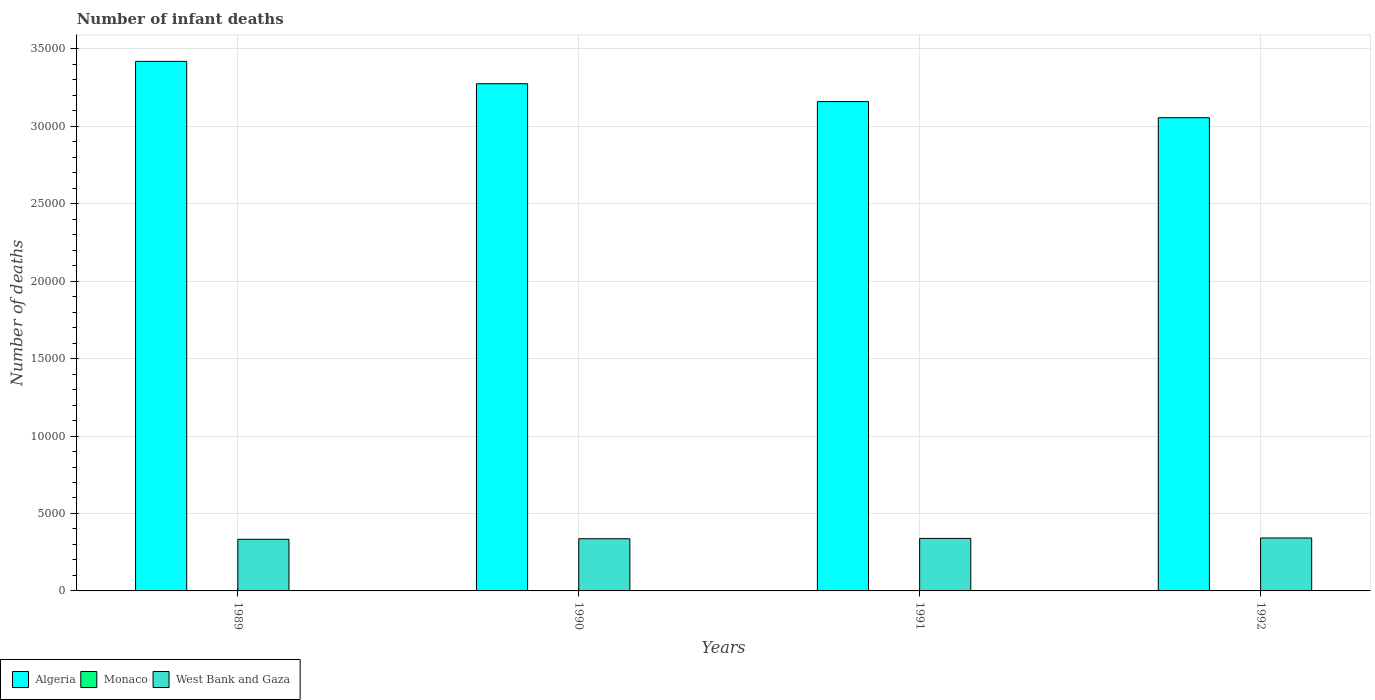How many different coloured bars are there?
Offer a terse response. 3. Are the number of bars per tick equal to the number of legend labels?
Provide a short and direct response. Yes. Are the number of bars on each tick of the X-axis equal?
Your response must be concise. Yes. What is the number of infant deaths in Monaco in 1992?
Give a very brief answer. 2. Across all years, what is the maximum number of infant deaths in Algeria?
Ensure brevity in your answer.  3.42e+04. Across all years, what is the minimum number of infant deaths in Monaco?
Ensure brevity in your answer.  1. In which year was the number of infant deaths in Monaco maximum?
Your answer should be very brief. 1990. In which year was the number of infant deaths in West Bank and Gaza minimum?
Give a very brief answer. 1989. What is the total number of infant deaths in West Bank and Gaza in the graph?
Offer a terse response. 1.35e+04. What is the difference between the number of infant deaths in Algeria in 1990 and that in 1992?
Provide a succinct answer. 2193. What is the difference between the number of infant deaths in Monaco in 1989 and the number of infant deaths in West Bank and Gaza in 1991?
Keep it short and to the point. -3389. What is the average number of infant deaths in Algeria per year?
Your answer should be compact. 3.23e+04. In the year 1990, what is the difference between the number of infant deaths in West Bank and Gaza and number of infant deaths in Monaco?
Keep it short and to the point. 3367. What is the ratio of the number of infant deaths in Monaco in 1990 to that in 1992?
Ensure brevity in your answer.  1. Is the number of infant deaths in West Bank and Gaza in 1989 less than that in 1991?
Offer a very short reply. Yes. Is the difference between the number of infant deaths in West Bank and Gaza in 1990 and 1992 greater than the difference between the number of infant deaths in Monaco in 1990 and 1992?
Provide a succinct answer. No. What is the difference between the highest and the second highest number of infant deaths in Algeria?
Provide a short and direct response. 1445. What is the difference between the highest and the lowest number of infant deaths in Algeria?
Keep it short and to the point. 3638. What does the 3rd bar from the left in 1991 represents?
Your response must be concise. West Bank and Gaza. What does the 2nd bar from the right in 1990 represents?
Give a very brief answer. Monaco. How many bars are there?
Your answer should be compact. 12. Where does the legend appear in the graph?
Provide a succinct answer. Bottom left. How are the legend labels stacked?
Provide a short and direct response. Horizontal. What is the title of the graph?
Provide a succinct answer. Number of infant deaths. Does "Israel" appear as one of the legend labels in the graph?
Make the answer very short. No. What is the label or title of the Y-axis?
Offer a very short reply. Number of deaths. What is the Number of deaths of Algeria in 1989?
Offer a terse response. 3.42e+04. What is the Number of deaths of West Bank and Gaza in 1989?
Provide a short and direct response. 3335. What is the Number of deaths of Algeria in 1990?
Keep it short and to the point. 3.27e+04. What is the Number of deaths in Monaco in 1990?
Give a very brief answer. 2. What is the Number of deaths of West Bank and Gaza in 1990?
Your answer should be compact. 3369. What is the Number of deaths in Algeria in 1991?
Give a very brief answer. 3.16e+04. What is the Number of deaths in West Bank and Gaza in 1991?
Offer a very short reply. 3390. What is the Number of deaths in Algeria in 1992?
Your response must be concise. 3.06e+04. What is the Number of deaths in Monaco in 1992?
Provide a short and direct response. 2. What is the Number of deaths in West Bank and Gaza in 1992?
Give a very brief answer. 3417. Across all years, what is the maximum Number of deaths of Algeria?
Provide a succinct answer. 3.42e+04. Across all years, what is the maximum Number of deaths in West Bank and Gaza?
Offer a terse response. 3417. Across all years, what is the minimum Number of deaths of Algeria?
Your answer should be compact. 3.06e+04. Across all years, what is the minimum Number of deaths of Monaco?
Provide a succinct answer. 1. Across all years, what is the minimum Number of deaths in West Bank and Gaza?
Ensure brevity in your answer.  3335. What is the total Number of deaths in Algeria in the graph?
Offer a terse response. 1.29e+05. What is the total Number of deaths in Monaco in the graph?
Provide a succinct answer. 7. What is the total Number of deaths in West Bank and Gaza in the graph?
Keep it short and to the point. 1.35e+04. What is the difference between the Number of deaths of Algeria in 1989 and that in 1990?
Your answer should be compact. 1445. What is the difference between the Number of deaths of Monaco in 1989 and that in 1990?
Your response must be concise. -1. What is the difference between the Number of deaths of West Bank and Gaza in 1989 and that in 1990?
Make the answer very short. -34. What is the difference between the Number of deaths in Algeria in 1989 and that in 1991?
Give a very brief answer. 2598. What is the difference between the Number of deaths in Monaco in 1989 and that in 1991?
Keep it short and to the point. -1. What is the difference between the Number of deaths of West Bank and Gaza in 1989 and that in 1991?
Provide a short and direct response. -55. What is the difference between the Number of deaths in Algeria in 1989 and that in 1992?
Your answer should be very brief. 3638. What is the difference between the Number of deaths of West Bank and Gaza in 1989 and that in 1992?
Make the answer very short. -82. What is the difference between the Number of deaths of Algeria in 1990 and that in 1991?
Keep it short and to the point. 1153. What is the difference between the Number of deaths in West Bank and Gaza in 1990 and that in 1991?
Offer a very short reply. -21. What is the difference between the Number of deaths of Algeria in 1990 and that in 1992?
Provide a short and direct response. 2193. What is the difference between the Number of deaths of West Bank and Gaza in 1990 and that in 1992?
Make the answer very short. -48. What is the difference between the Number of deaths in Algeria in 1991 and that in 1992?
Your response must be concise. 1040. What is the difference between the Number of deaths of Monaco in 1991 and that in 1992?
Offer a very short reply. 0. What is the difference between the Number of deaths in Algeria in 1989 and the Number of deaths in Monaco in 1990?
Offer a terse response. 3.42e+04. What is the difference between the Number of deaths in Algeria in 1989 and the Number of deaths in West Bank and Gaza in 1990?
Keep it short and to the point. 3.08e+04. What is the difference between the Number of deaths of Monaco in 1989 and the Number of deaths of West Bank and Gaza in 1990?
Offer a terse response. -3368. What is the difference between the Number of deaths of Algeria in 1989 and the Number of deaths of Monaco in 1991?
Offer a terse response. 3.42e+04. What is the difference between the Number of deaths in Algeria in 1989 and the Number of deaths in West Bank and Gaza in 1991?
Ensure brevity in your answer.  3.08e+04. What is the difference between the Number of deaths in Monaco in 1989 and the Number of deaths in West Bank and Gaza in 1991?
Give a very brief answer. -3389. What is the difference between the Number of deaths of Algeria in 1989 and the Number of deaths of Monaco in 1992?
Provide a succinct answer. 3.42e+04. What is the difference between the Number of deaths in Algeria in 1989 and the Number of deaths in West Bank and Gaza in 1992?
Make the answer very short. 3.08e+04. What is the difference between the Number of deaths of Monaco in 1989 and the Number of deaths of West Bank and Gaza in 1992?
Your response must be concise. -3416. What is the difference between the Number of deaths in Algeria in 1990 and the Number of deaths in Monaco in 1991?
Provide a short and direct response. 3.27e+04. What is the difference between the Number of deaths of Algeria in 1990 and the Number of deaths of West Bank and Gaza in 1991?
Offer a terse response. 2.94e+04. What is the difference between the Number of deaths of Monaco in 1990 and the Number of deaths of West Bank and Gaza in 1991?
Make the answer very short. -3388. What is the difference between the Number of deaths in Algeria in 1990 and the Number of deaths in Monaco in 1992?
Keep it short and to the point. 3.27e+04. What is the difference between the Number of deaths of Algeria in 1990 and the Number of deaths of West Bank and Gaza in 1992?
Your answer should be very brief. 2.93e+04. What is the difference between the Number of deaths in Monaco in 1990 and the Number of deaths in West Bank and Gaza in 1992?
Your response must be concise. -3415. What is the difference between the Number of deaths of Algeria in 1991 and the Number of deaths of Monaco in 1992?
Ensure brevity in your answer.  3.16e+04. What is the difference between the Number of deaths in Algeria in 1991 and the Number of deaths in West Bank and Gaza in 1992?
Provide a succinct answer. 2.82e+04. What is the difference between the Number of deaths of Monaco in 1991 and the Number of deaths of West Bank and Gaza in 1992?
Keep it short and to the point. -3415. What is the average Number of deaths of Algeria per year?
Give a very brief answer. 3.23e+04. What is the average Number of deaths in West Bank and Gaza per year?
Offer a terse response. 3377.75. In the year 1989, what is the difference between the Number of deaths in Algeria and Number of deaths in Monaco?
Provide a succinct answer. 3.42e+04. In the year 1989, what is the difference between the Number of deaths in Algeria and Number of deaths in West Bank and Gaza?
Offer a very short reply. 3.09e+04. In the year 1989, what is the difference between the Number of deaths in Monaco and Number of deaths in West Bank and Gaza?
Keep it short and to the point. -3334. In the year 1990, what is the difference between the Number of deaths in Algeria and Number of deaths in Monaco?
Your response must be concise. 3.27e+04. In the year 1990, what is the difference between the Number of deaths in Algeria and Number of deaths in West Bank and Gaza?
Make the answer very short. 2.94e+04. In the year 1990, what is the difference between the Number of deaths of Monaco and Number of deaths of West Bank and Gaza?
Ensure brevity in your answer.  -3367. In the year 1991, what is the difference between the Number of deaths of Algeria and Number of deaths of Monaco?
Keep it short and to the point. 3.16e+04. In the year 1991, what is the difference between the Number of deaths in Algeria and Number of deaths in West Bank and Gaza?
Your response must be concise. 2.82e+04. In the year 1991, what is the difference between the Number of deaths in Monaco and Number of deaths in West Bank and Gaza?
Ensure brevity in your answer.  -3388. In the year 1992, what is the difference between the Number of deaths in Algeria and Number of deaths in Monaco?
Ensure brevity in your answer.  3.06e+04. In the year 1992, what is the difference between the Number of deaths in Algeria and Number of deaths in West Bank and Gaza?
Make the answer very short. 2.71e+04. In the year 1992, what is the difference between the Number of deaths in Monaco and Number of deaths in West Bank and Gaza?
Keep it short and to the point. -3415. What is the ratio of the Number of deaths in Algeria in 1989 to that in 1990?
Keep it short and to the point. 1.04. What is the ratio of the Number of deaths of Algeria in 1989 to that in 1991?
Give a very brief answer. 1.08. What is the ratio of the Number of deaths of West Bank and Gaza in 1989 to that in 1991?
Offer a very short reply. 0.98. What is the ratio of the Number of deaths in Algeria in 1989 to that in 1992?
Make the answer very short. 1.12. What is the ratio of the Number of deaths of West Bank and Gaza in 1989 to that in 1992?
Offer a very short reply. 0.98. What is the ratio of the Number of deaths of Algeria in 1990 to that in 1991?
Ensure brevity in your answer.  1.04. What is the ratio of the Number of deaths in Monaco in 1990 to that in 1991?
Your answer should be very brief. 1. What is the ratio of the Number of deaths of West Bank and Gaza in 1990 to that in 1991?
Your answer should be very brief. 0.99. What is the ratio of the Number of deaths of Algeria in 1990 to that in 1992?
Keep it short and to the point. 1.07. What is the ratio of the Number of deaths of West Bank and Gaza in 1990 to that in 1992?
Keep it short and to the point. 0.99. What is the ratio of the Number of deaths of Algeria in 1991 to that in 1992?
Provide a succinct answer. 1.03. What is the ratio of the Number of deaths of Monaco in 1991 to that in 1992?
Make the answer very short. 1. What is the difference between the highest and the second highest Number of deaths of Algeria?
Offer a very short reply. 1445. What is the difference between the highest and the second highest Number of deaths of Monaco?
Your answer should be very brief. 0. What is the difference between the highest and the second highest Number of deaths of West Bank and Gaza?
Provide a succinct answer. 27. What is the difference between the highest and the lowest Number of deaths in Algeria?
Your answer should be very brief. 3638. What is the difference between the highest and the lowest Number of deaths in West Bank and Gaza?
Give a very brief answer. 82. 